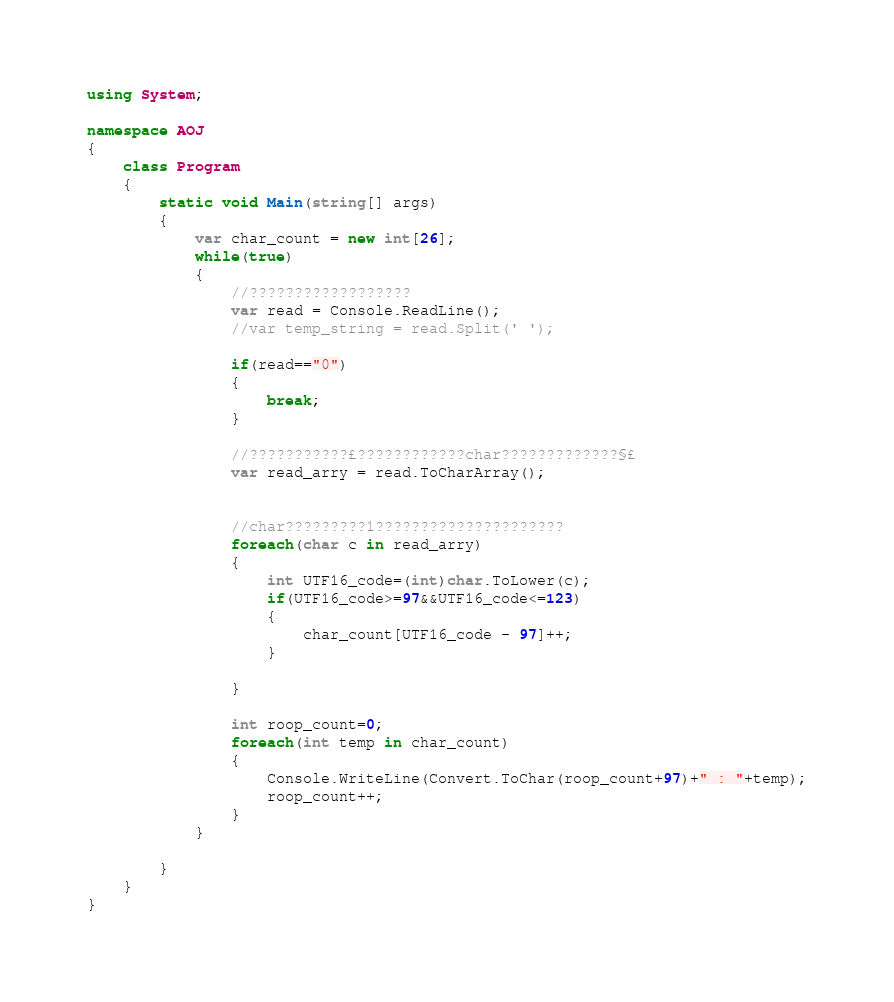Convert code to text. <code><loc_0><loc_0><loc_500><loc_500><_C#_>using System;

namespace AOJ
{
    class Program
    {
        static void Main(string[] args)
        {
            var char_count = new int[26];
            while(true)
            {
                //??????????????????
                var read = Console.ReadLine();
                //var temp_string = read.Split(' ');

                if(read=="0")
                {
                    break;
                }

                //???????????£????????????char?????????????§£
                var read_arry = read.ToCharArray();


                //char?????????1?????????????????????
                foreach(char c in read_arry)
                {
                    int UTF16_code=(int)char.ToLower(c);
                    if(UTF16_code>=97&&UTF16_code<=123)
                    {
                        char_count[UTF16_code - 97]++;
                    }

                }

                int roop_count=0;
                foreach(int temp in char_count)
                {
                    Console.WriteLine(Convert.ToChar(roop_count+97)+" : "+temp);
                    roop_count++;
                }
            }
            
        }
    }
}</code> 